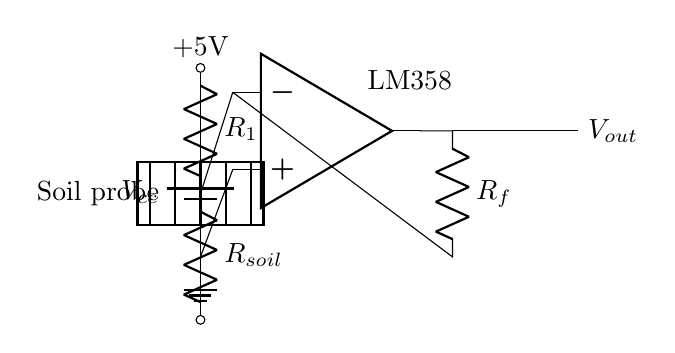What is the operational amplifier used in this circuit? The circuit indicates the use of the LM358, which is clearly labeled next to the operational amplifier symbol.
Answer: LM358 What is the function of the soil probe in this circuit? The soil probe represents the variable resistor (R_soil), which changes its resistance based on the moisture level in the soil, affecting the voltage divider output.
Answer: Measure soil moisture What is the supply voltage for this circuit? The circuit shows a battery labeled with a voltage of +5V directly connected to the components, establishing the supply voltage for the circuit.
Answer: 5V What role does R_f play in this circuit? The resistor R_f is part of the feedback loop connected from the output back to the negative input of the operational amplifier, influencing the gain of the op-amp and stabilizing its output.
Answer: Feedback resistor What happens to the output voltage as soil moisture increases? As soil moisture increases, the resistance of R_soil decreases, leading to a higher voltage at the input of the operational amplifier, which subsequently increases the output voltage due to the circuit's configuration.
Answer: Increases What is the effect of low soil moisture on R_soil? Low soil moisture results in high resistance of R_soil, leading to a lower voltage at the input of the operational amplifier and subsequently a lower output voltage, indicating drier conditions.
Answer: High resistance 